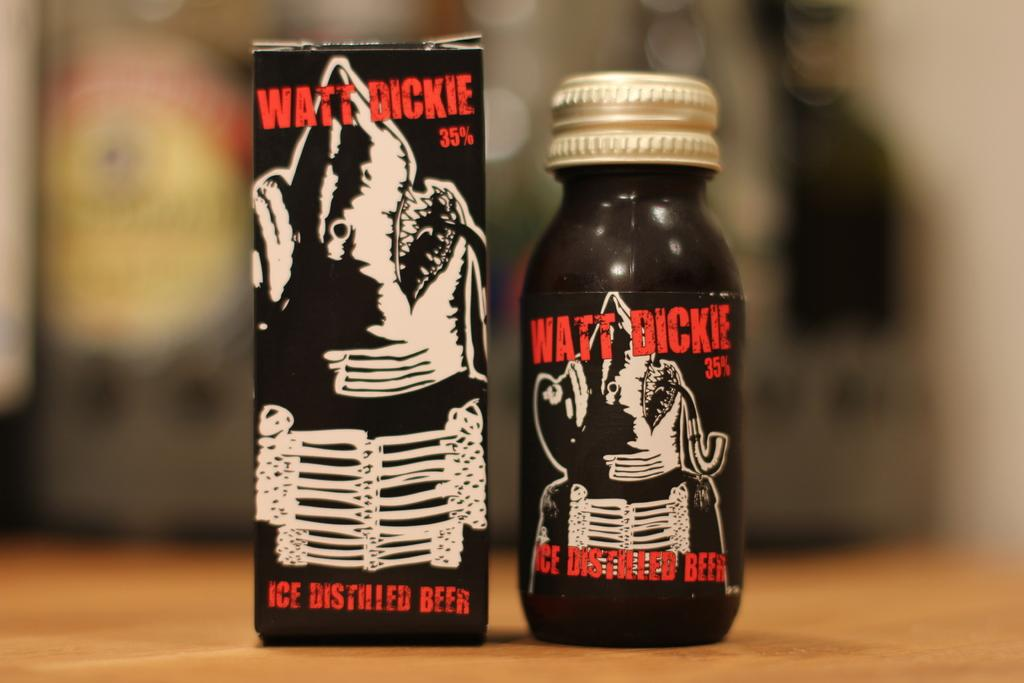<image>
Share a concise interpretation of the image provided. The beverage advertised in the box and bottle is 35% strong alcohol. 